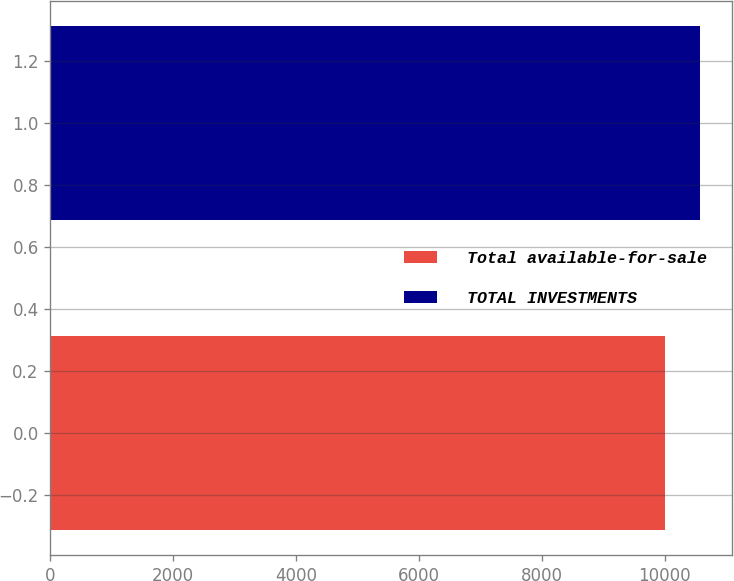Convert chart. <chart><loc_0><loc_0><loc_500><loc_500><bar_chart><fcel>Total available-for-sale<fcel>TOTAL INVESTMENTS<nl><fcel>10000<fcel>10571<nl></chart> 